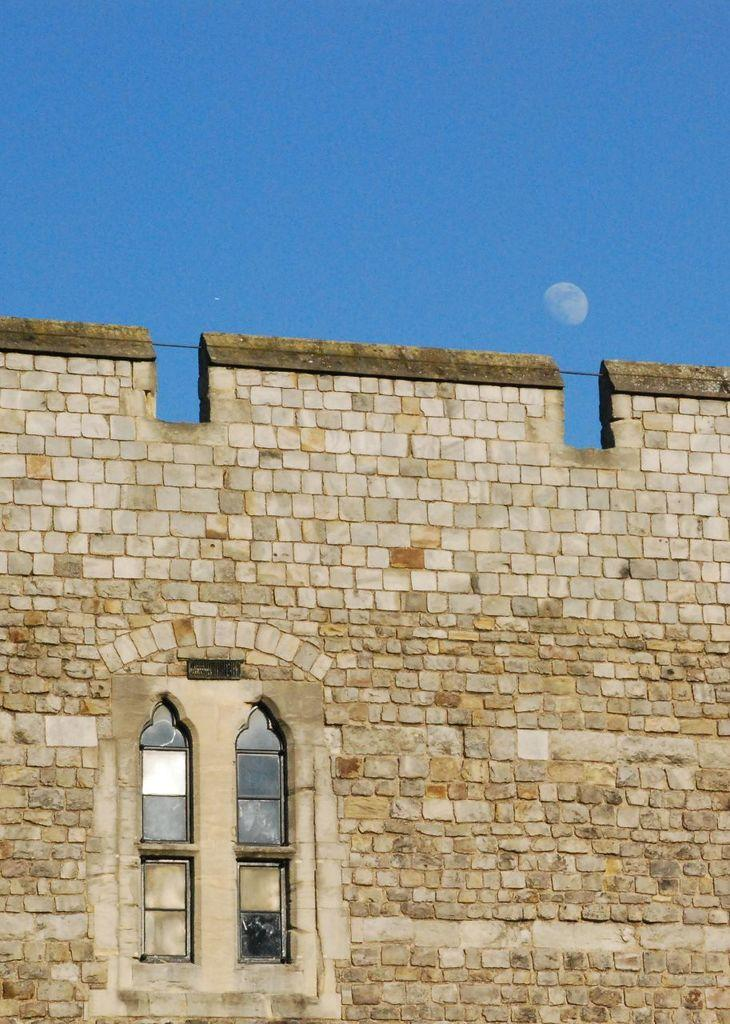What type of structure can be seen in the image? There is a wall in the image. Is there any opening in the wall? Yes, there is a window in the image. What can be seen outside the window? The moon and the sky are visible in the background of the image. How many zebras can be seen grazing in the background of the image? There are no zebras present in the image; it features a wall, a window, and a view of the moon and sky. 